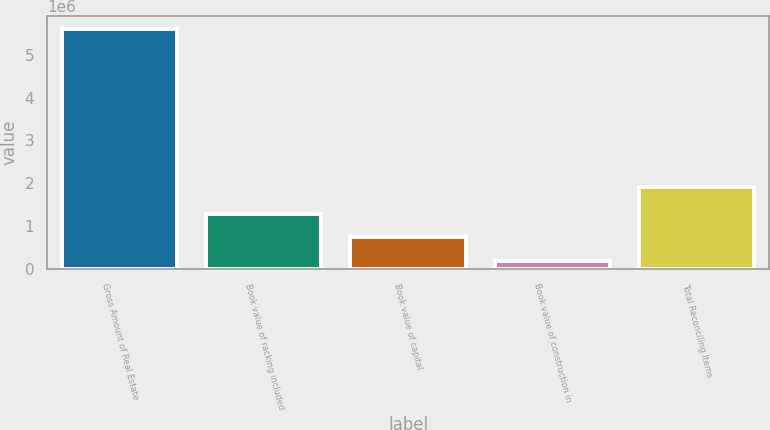Convert chart. <chart><loc_0><loc_0><loc_500><loc_500><bar_chart><fcel>Gross Amount of Real Estate<fcel>Book value of racking included<fcel>Book value of capital<fcel>Book value of construction in<fcel>Total Reconciling Items<nl><fcel>5.61228e+06<fcel>1.27947e+06<fcel>737869<fcel>196268<fcel>1.91197e+06<nl></chart> 